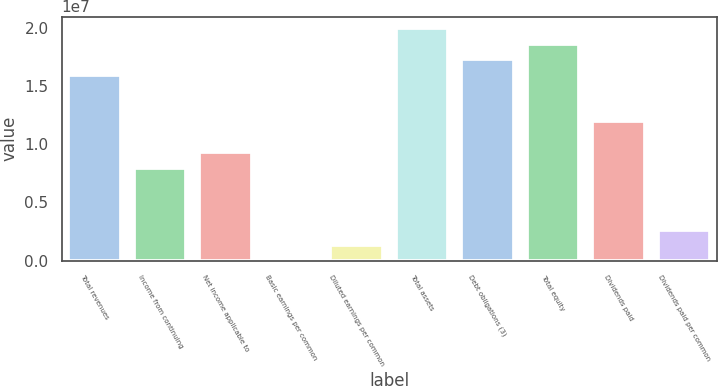<chart> <loc_0><loc_0><loc_500><loc_500><bar_chart><fcel>Total revenues<fcel>Income from continuing<fcel>Net income applicable to<fcel>Basic earnings per common<fcel>Diluted earnings per common<fcel>Total assets<fcel>Debt obligations (3)<fcel>Total equity<fcel>Dividends paid<fcel>Dividends paid per common<nl><fcel>1.59983e+07<fcel>7.99915e+06<fcel>9.33235e+06<fcel>0.87<fcel>1.33319e+06<fcel>1.99979e+07<fcel>1.73315e+07<fcel>1.86647e+07<fcel>1.19987e+07<fcel>2.66639e+06<nl></chart> 